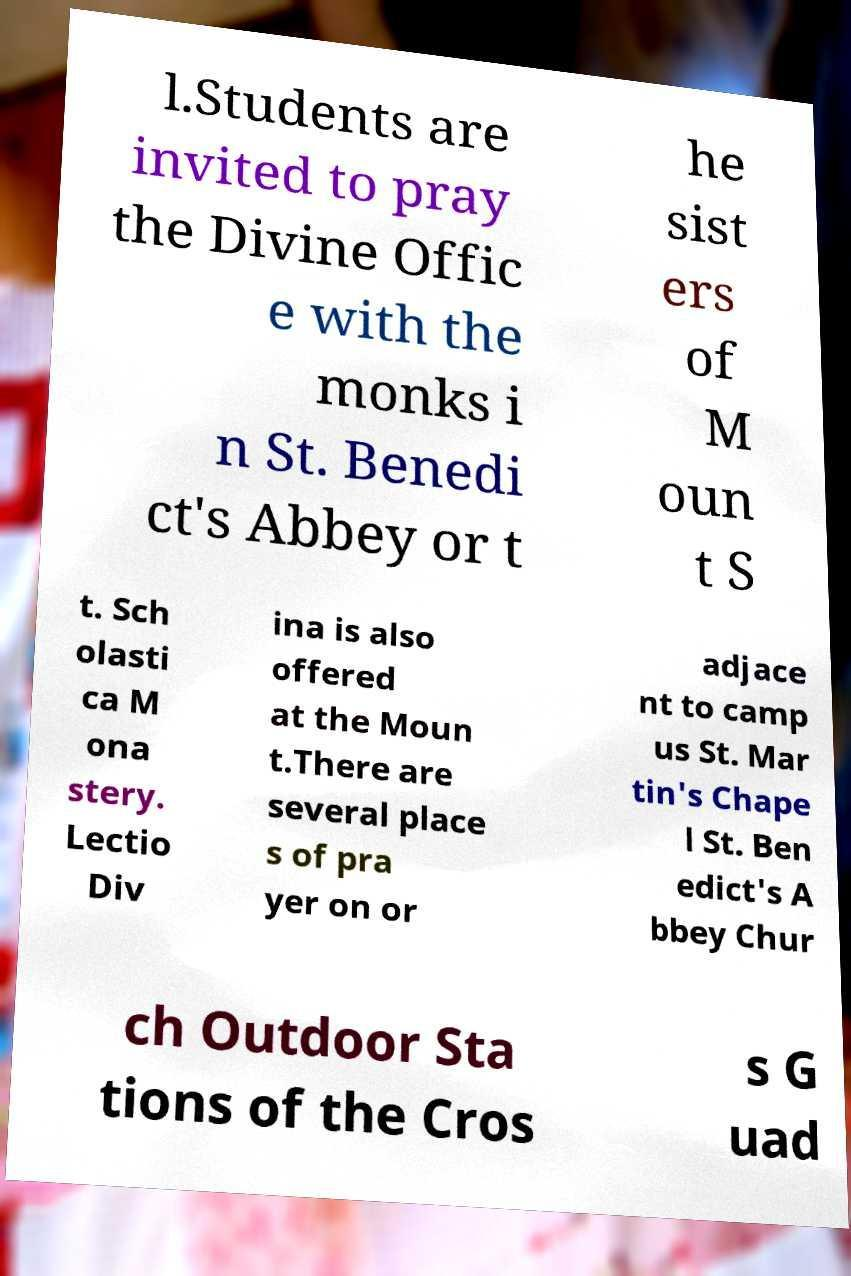Can you accurately transcribe the text from the provided image for me? l.Students are invited to pray the Divine Offic e with the monks i n St. Benedi ct's Abbey or t he sist ers of M oun t S t. Sch olasti ca M ona stery. Lectio Div ina is also offered at the Moun t.There are several place s of pra yer on or adjace nt to camp us St. Mar tin's Chape l St. Ben edict's A bbey Chur ch Outdoor Sta tions of the Cros s G uad 